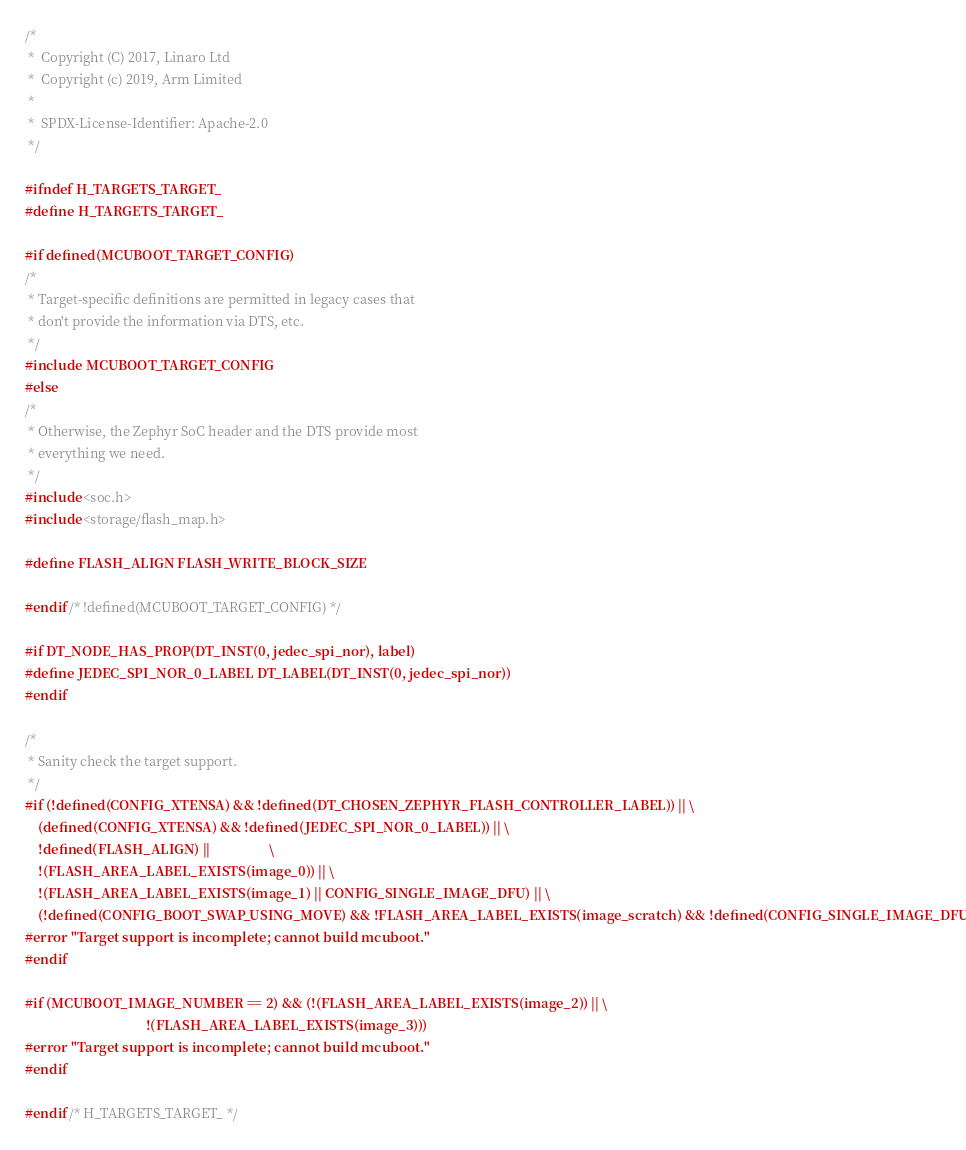<code> <loc_0><loc_0><loc_500><loc_500><_C_>/*
 *  Copyright (C) 2017, Linaro Ltd
 *  Copyright (c) 2019, Arm Limited
 *
 *  SPDX-License-Identifier: Apache-2.0
 */

#ifndef H_TARGETS_TARGET_
#define H_TARGETS_TARGET_

#if defined(MCUBOOT_TARGET_CONFIG)
/*
 * Target-specific definitions are permitted in legacy cases that
 * don't provide the information via DTS, etc.
 */
#include MCUBOOT_TARGET_CONFIG
#else
/*
 * Otherwise, the Zephyr SoC header and the DTS provide most
 * everything we need.
 */
#include <soc.h>
#include <storage/flash_map.h>

#define FLASH_ALIGN FLASH_WRITE_BLOCK_SIZE

#endif /* !defined(MCUBOOT_TARGET_CONFIG) */

#if DT_NODE_HAS_PROP(DT_INST(0, jedec_spi_nor), label)
#define JEDEC_SPI_NOR_0_LABEL DT_LABEL(DT_INST(0, jedec_spi_nor))
#endif

/*
 * Sanity check the target support.
 */
#if (!defined(CONFIG_XTENSA) && !defined(DT_CHOSEN_ZEPHYR_FLASH_CONTROLLER_LABEL)) || \
    (defined(CONFIG_XTENSA) && !defined(JEDEC_SPI_NOR_0_LABEL)) || \
    !defined(FLASH_ALIGN) ||                  \
    !(FLASH_AREA_LABEL_EXISTS(image_0)) || \
    !(FLASH_AREA_LABEL_EXISTS(image_1) || CONFIG_SINGLE_IMAGE_DFU) || \
    (!defined(CONFIG_BOOT_SWAP_USING_MOVE) && !FLASH_AREA_LABEL_EXISTS(image_scratch) && !defined(CONFIG_SINGLE_IMAGE_DFU))
#error "Target support is incomplete; cannot build mcuboot."
#endif

#if (MCUBOOT_IMAGE_NUMBER == 2) && (!(FLASH_AREA_LABEL_EXISTS(image_2)) || \
                                     !(FLASH_AREA_LABEL_EXISTS(image_3)))
#error "Target support is incomplete; cannot build mcuboot."
#endif

#endif /* H_TARGETS_TARGET_ */
</code> 